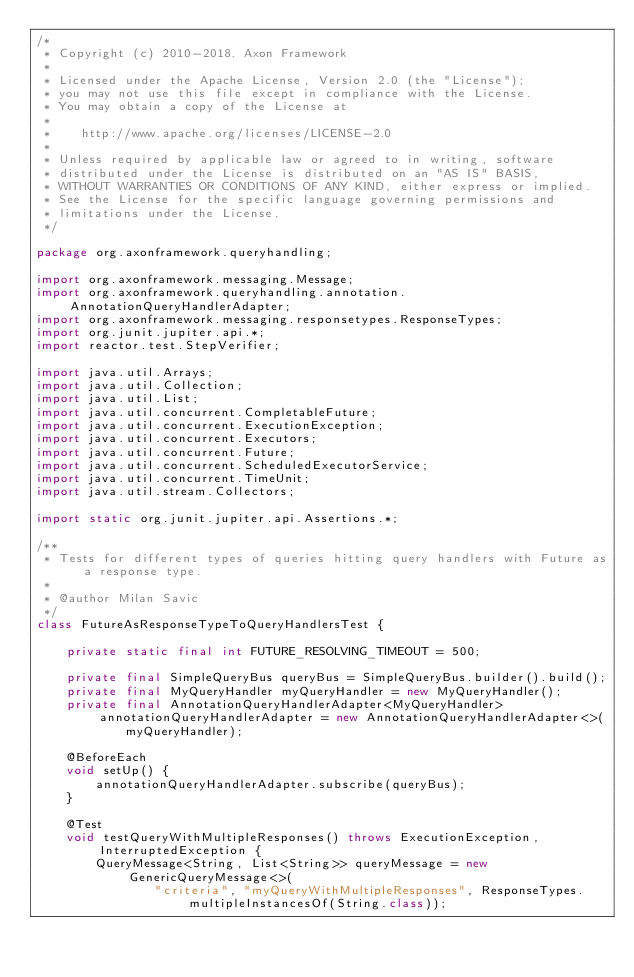Convert code to text. <code><loc_0><loc_0><loc_500><loc_500><_Java_>/*
 * Copyright (c) 2010-2018. Axon Framework
 *
 * Licensed under the Apache License, Version 2.0 (the "License");
 * you may not use this file except in compliance with the License.
 * You may obtain a copy of the License at
 *
 *    http://www.apache.org/licenses/LICENSE-2.0
 *
 * Unless required by applicable law or agreed to in writing, software
 * distributed under the License is distributed on an "AS IS" BASIS,
 * WITHOUT WARRANTIES OR CONDITIONS OF ANY KIND, either express or implied.
 * See the License for the specific language governing permissions and
 * limitations under the License.
 */

package org.axonframework.queryhandling;

import org.axonframework.messaging.Message;
import org.axonframework.queryhandling.annotation.AnnotationQueryHandlerAdapter;
import org.axonframework.messaging.responsetypes.ResponseTypes;
import org.junit.jupiter.api.*;
import reactor.test.StepVerifier;

import java.util.Arrays;
import java.util.Collection;
import java.util.List;
import java.util.concurrent.CompletableFuture;
import java.util.concurrent.ExecutionException;
import java.util.concurrent.Executors;
import java.util.concurrent.Future;
import java.util.concurrent.ScheduledExecutorService;
import java.util.concurrent.TimeUnit;
import java.util.stream.Collectors;

import static org.junit.jupiter.api.Assertions.*;

/**
 * Tests for different types of queries hitting query handlers with Future as a response type.
 *
 * @author Milan Savic
 */
class FutureAsResponseTypeToQueryHandlersTest {

    private static final int FUTURE_RESOLVING_TIMEOUT = 500;

    private final SimpleQueryBus queryBus = SimpleQueryBus.builder().build();
    private final MyQueryHandler myQueryHandler = new MyQueryHandler();
    private final AnnotationQueryHandlerAdapter<MyQueryHandler> annotationQueryHandlerAdapter = new AnnotationQueryHandlerAdapter<>(
            myQueryHandler);

    @BeforeEach
    void setUp() {
        annotationQueryHandlerAdapter.subscribe(queryBus);
    }

    @Test
    void testQueryWithMultipleResponses() throws ExecutionException, InterruptedException {
        QueryMessage<String, List<String>> queryMessage = new GenericQueryMessage<>(
                "criteria", "myQueryWithMultipleResponses", ResponseTypes.multipleInstancesOf(String.class));
</code> 